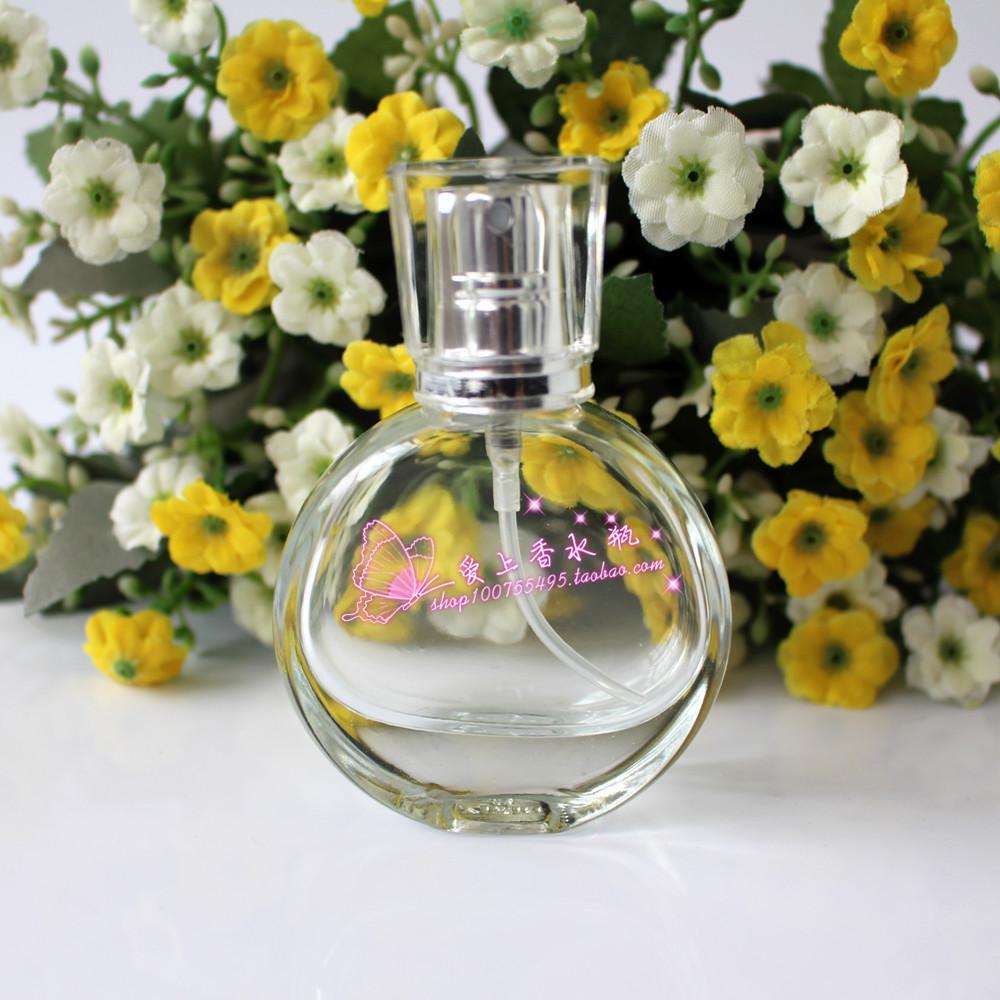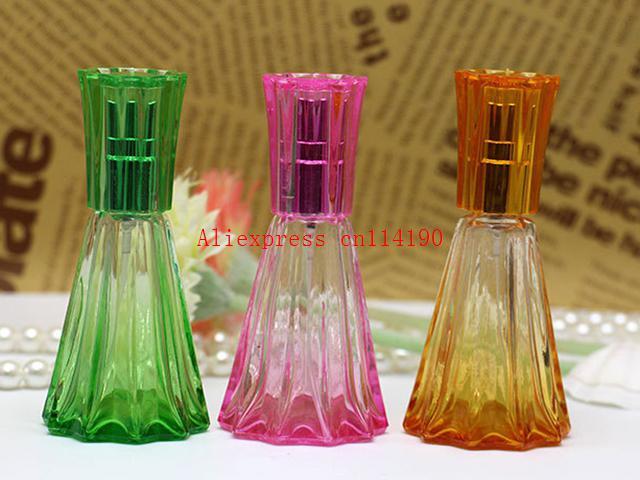The first image is the image on the left, the second image is the image on the right. Examine the images to the left and right. Is the description "An image includes fragrance bottles sitting on a round mirrored tray with scalloped edges." accurate? Answer yes or no. No. The first image is the image on the left, the second image is the image on the right. Evaluate the accuracy of this statement regarding the images: "At least one image is less than four fragrances.". Is it true? Answer yes or no. Yes. 